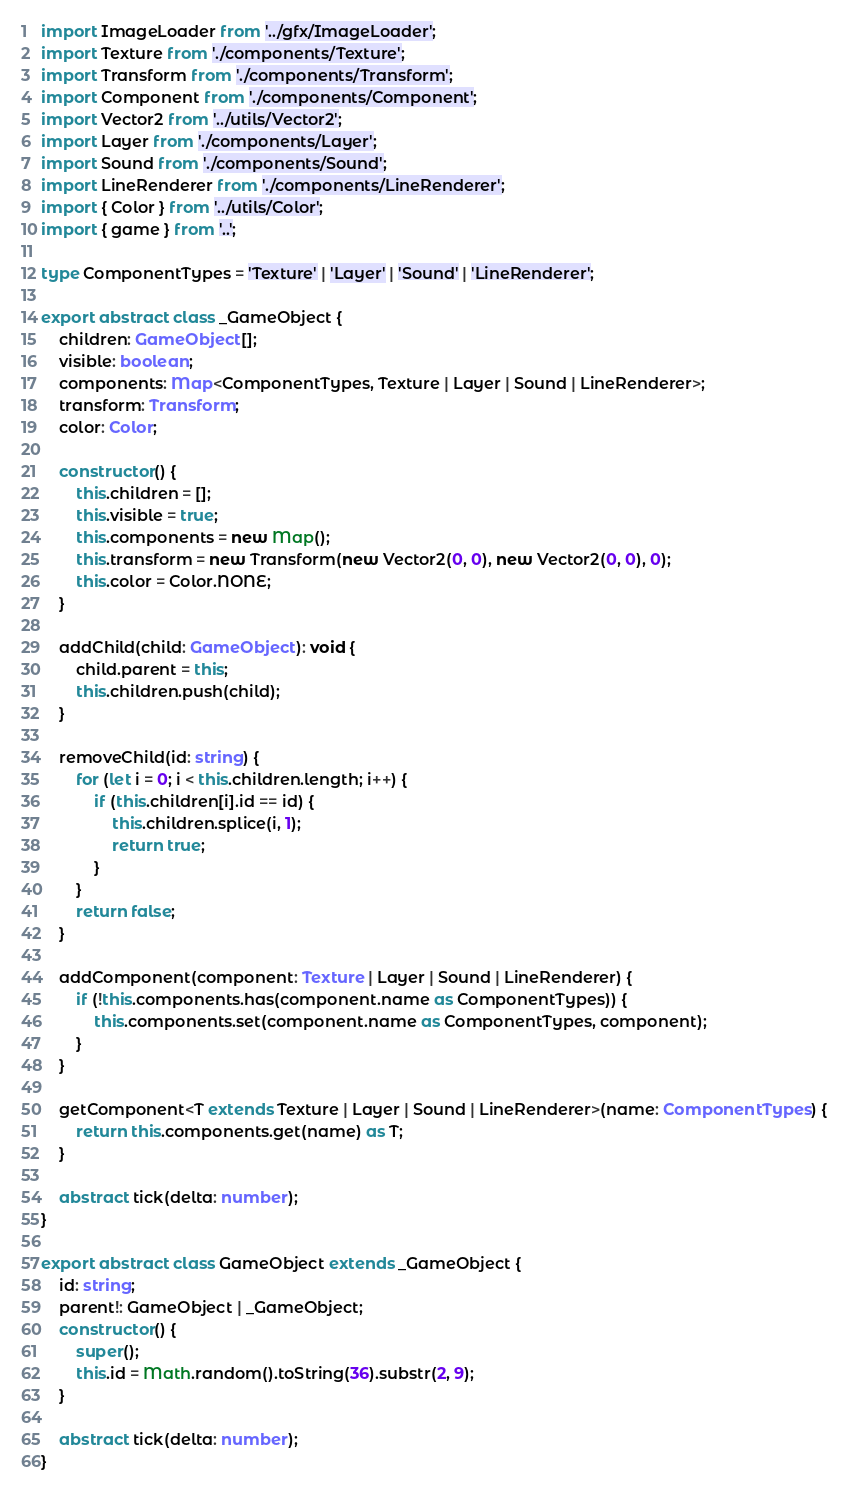Convert code to text. <code><loc_0><loc_0><loc_500><loc_500><_TypeScript_>import ImageLoader from '../gfx/ImageLoader';
import Texture from './components/Texture';
import Transform from './components/Transform';
import Component from './components/Component';
import Vector2 from '../utils/Vector2';
import Layer from './components/Layer';
import Sound from './components/Sound';
import LineRenderer from './components/LineRenderer';
import { Color } from '../utils/Color';
import { game } from '..';

type ComponentTypes = 'Texture' | 'Layer' | 'Sound' | 'LineRenderer';

export abstract class _GameObject {
	children: GameObject[];
	visible: boolean;
	components: Map<ComponentTypes, Texture | Layer | Sound | LineRenderer>;
	transform: Transform;
	color: Color;

	constructor() {
		this.children = [];
		this.visible = true;
		this.components = new Map();
		this.transform = new Transform(new Vector2(0, 0), new Vector2(0, 0), 0);
		this.color = Color.NONE;
	}

	addChild(child: GameObject): void {
		child.parent = this;
		this.children.push(child);
	}

	removeChild(id: string) {
		for (let i = 0; i < this.children.length; i++) {
			if (this.children[i].id == id) {
				this.children.splice(i, 1);
				return true;
			}
		}
		return false;
	}

	addComponent(component: Texture | Layer | Sound | LineRenderer) {
		if (!this.components.has(component.name as ComponentTypes)) {
			this.components.set(component.name as ComponentTypes, component);
		}
	}

	getComponent<T extends Texture | Layer | Sound | LineRenderer>(name: ComponentTypes) {
		return this.components.get(name) as T;
	}

	abstract tick(delta: number);
}

export abstract class GameObject extends _GameObject {
	id: string;
	parent!: GameObject | _GameObject;
	constructor() {
		super();
		this.id = Math.random().toString(36).substr(2, 9);
	}

	abstract tick(delta: number);
}
</code> 